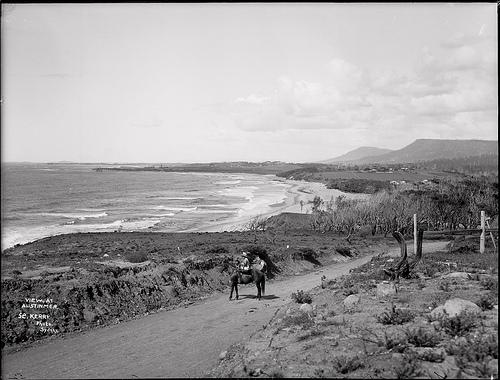Is this a color photograph?
Keep it brief. No. Is this a lonely road?
Concise answer only. Yes. How many animals are in the picture?
Be succinct. 1. Is the water choppy?
Short answer required. Yes. Is it cold out?
Short answer required. No. What is the fence line made of?
Write a very short answer. Wood. If this picture was in color, which sign would be red?
Keep it brief. 0. How many people are there?
Answer briefly. 2. Is this a good surfing spot for beginners?
Short answer required. No. Are there green leaves on the trees?
Answer briefly. No. Are those gravels next to the rail?
Concise answer only. No. How many animals are there?
Quick response, please. 1. Is this a boardwalk?
Answer briefly. No. What type of scene is this?
Concise answer only. Beach. Are there trees in the background?
Quick response, please. No. 